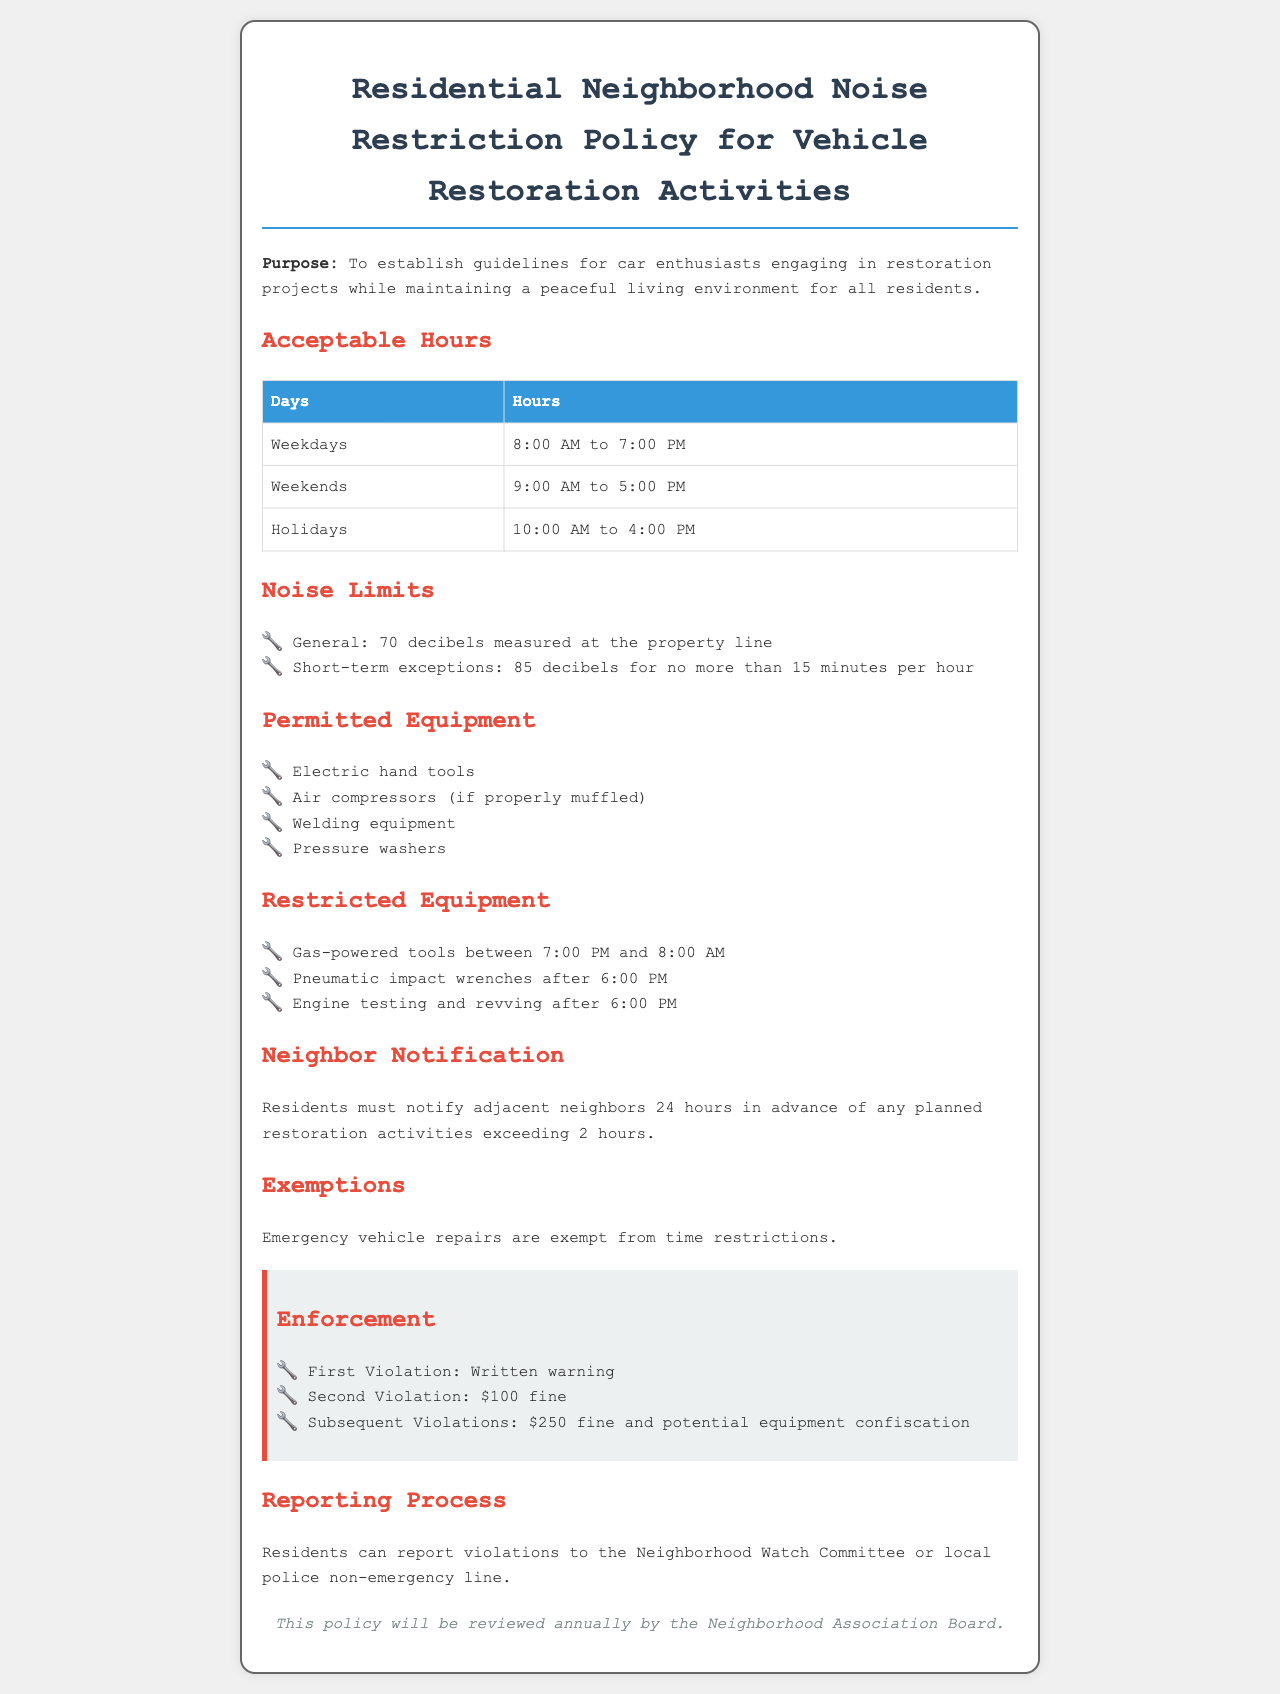What are the acceptable hours on weekdays? The document specifies the acceptable hours on weekdays as 8:00 AM to 7:00 PM.
Answer: 8:00 AM to 7:00 PM What is the noise limit for general activities? The document states that the general noise limit is 70 decibels measured at the property line.
Answer: 70 decibels What is the fine for the second violation? According to the enforcement section, the fine for the second violation is $100.
Answer: $100 What type of tools are restricted between 7:00 PM and 8:00 AM? The policy restricts gas-powered tools from being used between 7:00 PM and 8:00 AM.
Answer: Gas-powered tools How much notice must residents give neighbors for restoration activities? The document requires residents to notify adjacent neighbors 24 hours in advance for any planned activities exceeding 2 hours.
Answer: 24 hours What is the total noise limit for short-term exceptions? The policy allows short-term exceptions up to 85 decibels for no more than 15 minutes per hour.
Answer: 85 decibels How often will the policy be reviewed? The document states that the policy will be reviewed annually by the Neighborhood Association Board.
Answer: Annually What is the time frame for weekend activities? The acceptable time frame for weekend activities is 9:00 AM to 5:00 PM.
Answer: 9:00 AM to 5:00 PM 